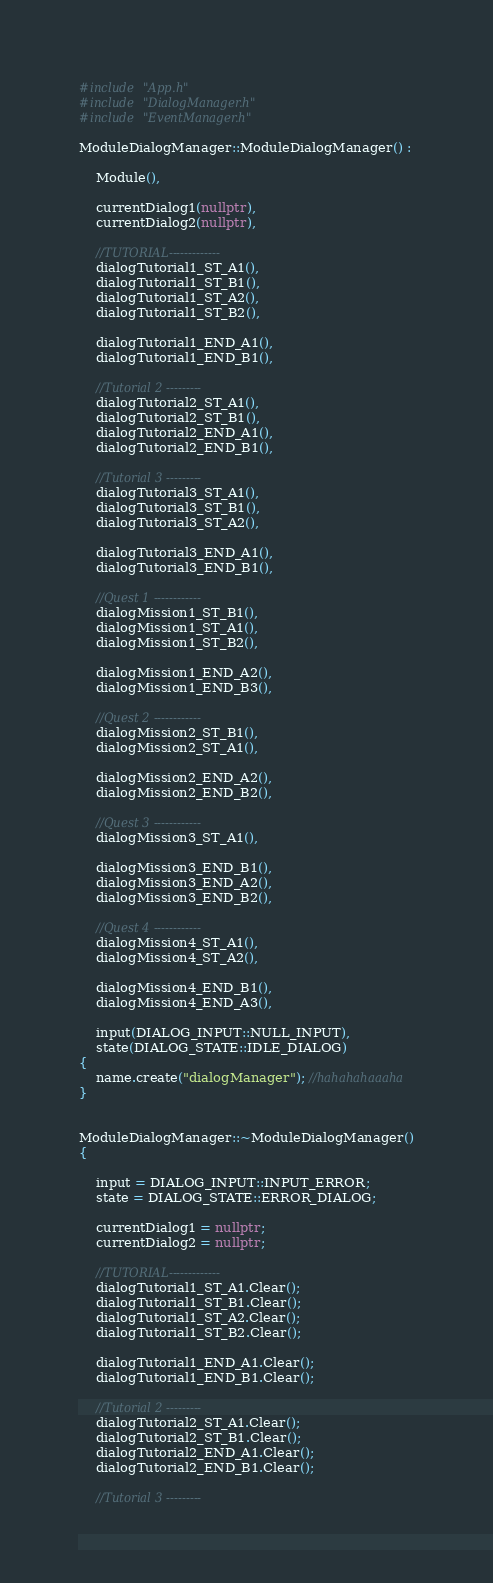<code> <loc_0><loc_0><loc_500><loc_500><_C++_>#include "App.h"
#include "DialogManager.h"
#include "EventManager.h"

ModuleDialogManager::ModuleDialogManager() :

	Module(),

	currentDialog1(nullptr),
	currentDialog2(nullptr),

	//TUTORIAL-------------
	dialogTutorial1_ST_A1(),
	dialogTutorial1_ST_B1(),
	dialogTutorial1_ST_A2(),
	dialogTutorial1_ST_B2(),

	dialogTutorial1_END_A1(),
	dialogTutorial1_END_B1(),

	//Tutorial 2 ---------
	dialogTutorial2_ST_A1(),
	dialogTutorial2_ST_B1(),
	dialogTutorial2_END_A1(),
	dialogTutorial2_END_B1(),

	//Tutorial 3 ---------
	dialogTutorial3_ST_A1(),
	dialogTutorial3_ST_B1(),
	dialogTutorial3_ST_A2(),

	dialogTutorial3_END_A1(),
	dialogTutorial3_END_B1(),

	//Quest 1 ------------
	dialogMission1_ST_B1(),
	dialogMission1_ST_A1(),
	dialogMission1_ST_B2(),

	dialogMission1_END_A2(),
	dialogMission1_END_B3(),

	//Quest 2 ------------
	dialogMission2_ST_B1(),
	dialogMission2_ST_A1(),

	dialogMission2_END_A2(),
	dialogMission2_END_B2(),

	//Quest 3 ------------
	dialogMission3_ST_A1(),

	dialogMission3_END_B1(),
	dialogMission3_END_A2(),
	dialogMission3_END_B2(),

	//Quest 4 ------------
	dialogMission4_ST_A1(),
	dialogMission4_ST_A2(),

	dialogMission4_END_B1(),
	dialogMission4_END_A3(),

	input(DIALOG_INPUT::NULL_INPUT),
	state(DIALOG_STATE::IDLE_DIALOG)
{
	name.create("dialogManager"); //hahahahaaaha
}


ModuleDialogManager::~ModuleDialogManager()
{

	input = DIALOG_INPUT::INPUT_ERROR;
	state = DIALOG_STATE::ERROR_DIALOG;

	currentDialog1 = nullptr;
	currentDialog2 = nullptr;

	//TUTORIAL-------------
	dialogTutorial1_ST_A1.Clear();
	dialogTutorial1_ST_B1.Clear();
	dialogTutorial1_ST_A2.Clear();
	dialogTutorial1_ST_B2.Clear();

	dialogTutorial1_END_A1.Clear();
	dialogTutorial1_END_B1.Clear();

	//Tutorial 2 ---------
	dialogTutorial2_ST_A1.Clear();
	dialogTutorial2_ST_B1.Clear();
	dialogTutorial2_END_A1.Clear();
	dialogTutorial2_END_B1.Clear();

	//Tutorial 3 ---------</code> 